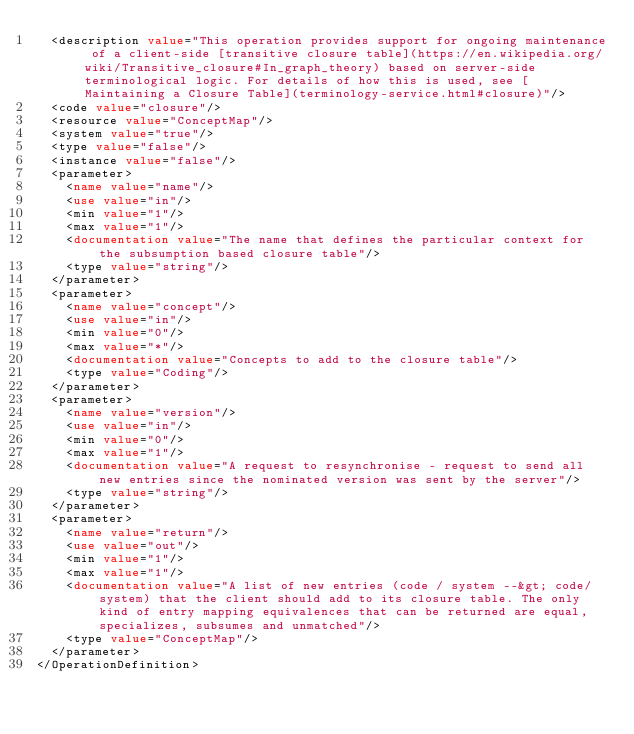<code> <loc_0><loc_0><loc_500><loc_500><_XML_>  <description value="This operation provides support for ongoing maintenance of a client-side [transitive closure table](https://en.wikipedia.org/wiki/Transitive_closure#In_graph_theory) based on server-side terminological logic. For details of how this is used, see [Maintaining a Closure Table](terminology-service.html#closure)"/>
  <code value="closure"/>
  <resource value="ConceptMap"/>
  <system value="true"/>
  <type value="false"/>
  <instance value="false"/>
  <parameter>
    <name value="name"/>
    <use value="in"/>
    <min value="1"/>
    <max value="1"/>
    <documentation value="The name that defines the particular context for the subsumption based closure table"/>
    <type value="string"/>
  </parameter>
  <parameter>
    <name value="concept"/>
    <use value="in"/>
    <min value="0"/>
    <max value="*"/>
    <documentation value="Concepts to add to the closure table"/>
    <type value="Coding"/>
  </parameter>
  <parameter>
    <name value="version"/>
    <use value="in"/>
    <min value="0"/>
    <max value="1"/>
    <documentation value="A request to resynchronise - request to send all new entries since the nominated version was sent by the server"/>
    <type value="string"/>
  </parameter>
  <parameter>
    <name value="return"/>
    <use value="out"/>
    <min value="1"/>
    <max value="1"/>
    <documentation value="A list of new entries (code / system --&gt; code/system) that the client should add to its closure table. The only kind of entry mapping equivalences that can be returned are equal, specializes, subsumes and unmatched"/>
    <type value="ConceptMap"/>
  </parameter>
</OperationDefinition>
</code> 